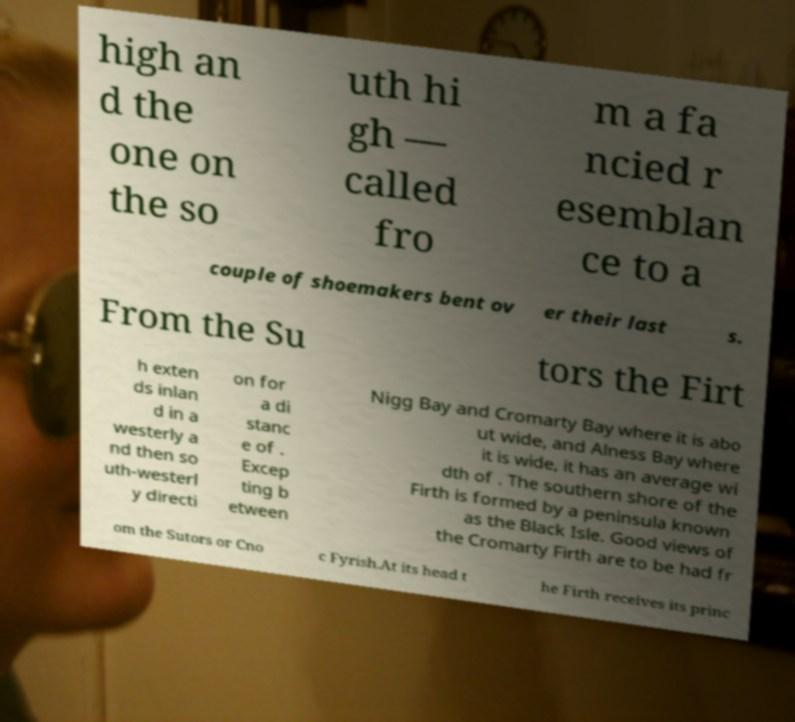For documentation purposes, I need the text within this image transcribed. Could you provide that? high an d the one on the so uth hi gh — called fro m a fa ncied r esemblan ce to a couple of shoemakers bent ov er their last s. From the Su tors the Firt h exten ds inlan d in a westerly a nd then so uth-westerl y directi on for a di stanc e of . Excep ting b etween Nigg Bay and Cromarty Bay where it is abo ut wide, and Alness Bay where it is wide, it has an average wi dth of . The southern shore of the Firth is formed by a peninsula known as the Black Isle. Good views of the Cromarty Firth are to be had fr om the Sutors or Cno c Fyrish.At its head t he Firth receives its princ 